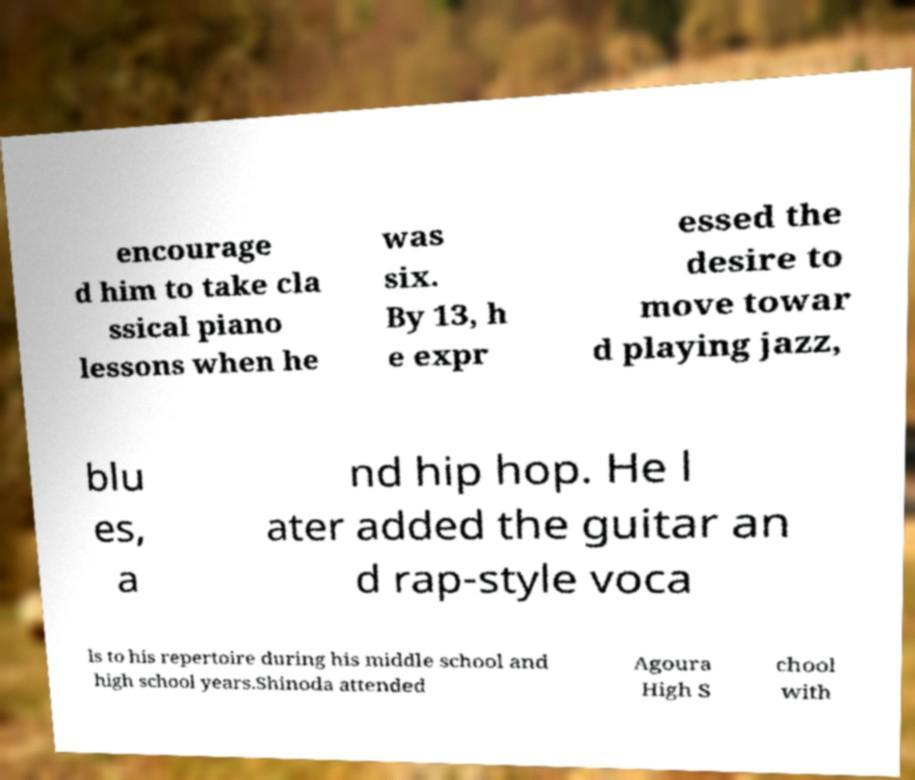I need the written content from this picture converted into text. Can you do that? encourage d him to take cla ssical piano lessons when he was six. By 13, h e expr essed the desire to move towar d playing jazz, blu es, a nd hip hop. He l ater added the guitar an d rap-style voca ls to his repertoire during his middle school and high school years.Shinoda attended Agoura High S chool with 